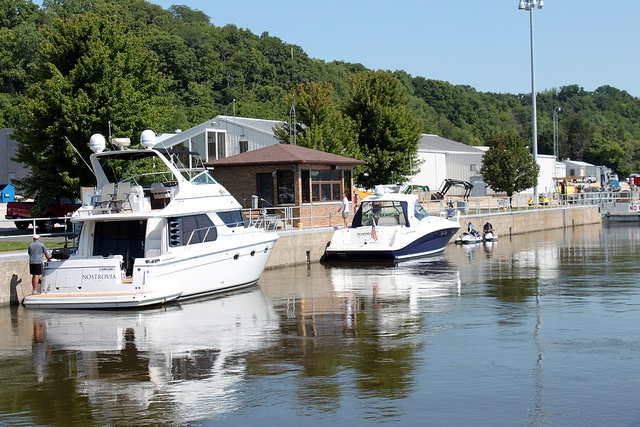Describe the objects in this image and their specific colors. I can see boat in black, white, darkgray, and gray tones, boat in black, white, darkgray, and gray tones, car in black, maroon, gray, and navy tones, boat in black, darkgray, gray, and lightgray tones, and people in black, gray, and darkgray tones in this image. 